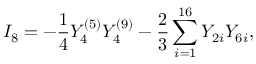Convert formula to latex. <formula><loc_0><loc_0><loc_500><loc_500>I _ { 8 } = - { \frac { 1 } { 4 } } Y _ { 4 } ^ { ( 5 ) } Y _ { 4 } ^ { ( 9 ) } - { \frac { 2 } { 3 } } \sum _ { i = 1 } ^ { 1 6 } Y _ { 2 i } Y _ { 6 i } ,</formula> 